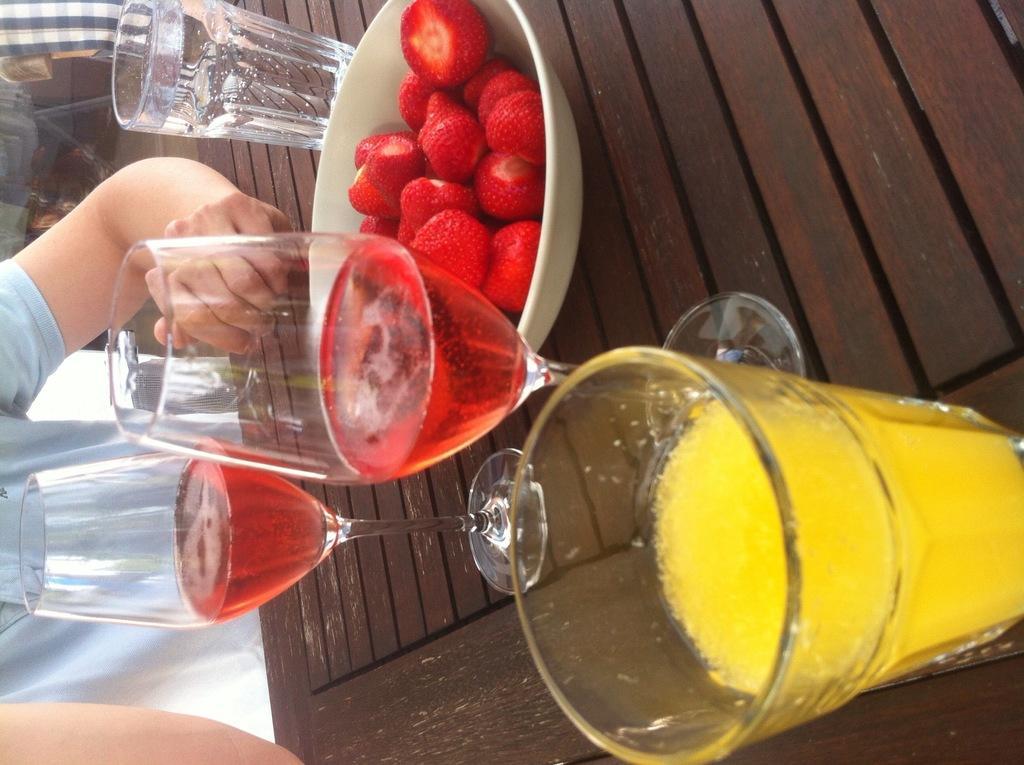How would you summarize this image in a sentence or two? This image is in left direction. On the right side, I can see a table on which a bowl which consists of strawberries in it, wine glasses are placed. On the left side, I can see a person holding this table and standing. 